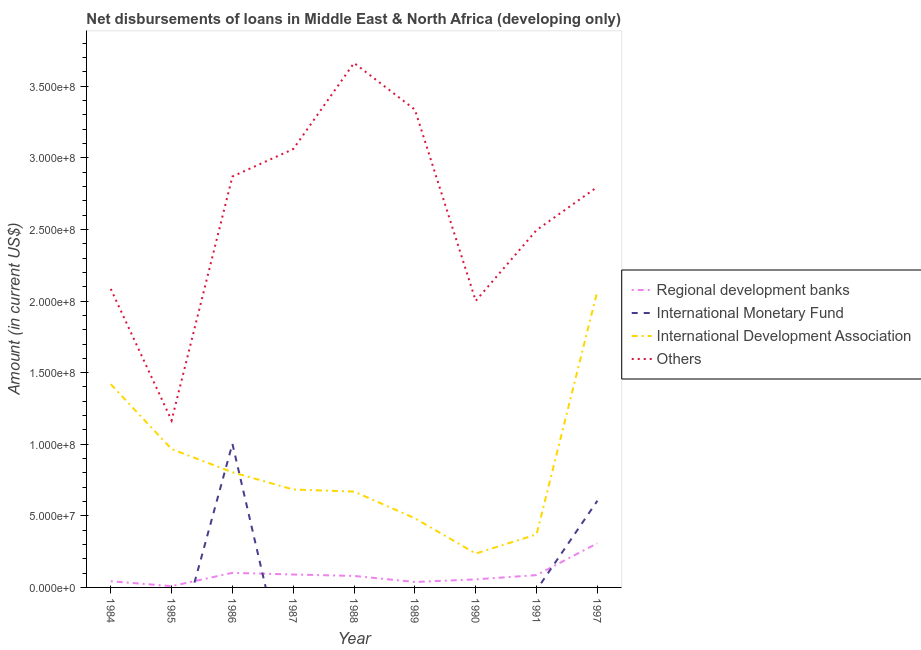Is the number of lines equal to the number of legend labels?
Make the answer very short. No. What is the amount of loan disimbursed by other organisations in 1984?
Ensure brevity in your answer.  2.08e+08. Across all years, what is the maximum amount of loan disimbursed by international monetary fund?
Provide a short and direct response. 1.00e+08. Across all years, what is the minimum amount of loan disimbursed by other organisations?
Keep it short and to the point. 1.17e+08. In which year was the amount of loan disimbursed by regional development banks maximum?
Ensure brevity in your answer.  1997. What is the total amount of loan disimbursed by other organisations in the graph?
Your answer should be very brief. 2.35e+09. What is the difference between the amount of loan disimbursed by other organisations in 1991 and that in 1997?
Ensure brevity in your answer.  -3.02e+07. What is the difference between the amount of loan disimbursed by other organisations in 1997 and the amount of loan disimbursed by international development association in 1988?
Make the answer very short. 2.13e+08. What is the average amount of loan disimbursed by international development association per year?
Provide a short and direct response. 8.56e+07. In the year 1986, what is the difference between the amount of loan disimbursed by other organisations and amount of loan disimbursed by international monetary fund?
Provide a succinct answer. 1.87e+08. What is the ratio of the amount of loan disimbursed by regional development banks in 1986 to that in 1987?
Provide a short and direct response. 1.13. Is the amount of loan disimbursed by regional development banks in 1986 less than that in 1989?
Make the answer very short. No. What is the difference between the highest and the second highest amount of loan disimbursed by other organisations?
Your response must be concise. 3.26e+07. What is the difference between the highest and the lowest amount of loan disimbursed by international monetary fund?
Keep it short and to the point. 1.00e+08. In how many years, is the amount of loan disimbursed by other organisations greater than the average amount of loan disimbursed by other organisations taken over all years?
Give a very brief answer. 5. Is it the case that in every year, the sum of the amount of loan disimbursed by regional development banks and amount of loan disimbursed by international monetary fund is greater than the amount of loan disimbursed by international development association?
Keep it short and to the point. No. Is the amount of loan disimbursed by other organisations strictly less than the amount of loan disimbursed by regional development banks over the years?
Make the answer very short. No. How many lines are there?
Make the answer very short. 4. Are the values on the major ticks of Y-axis written in scientific E-notation?
Ensure brevity in your answer.  Yes. Does the graph contain grids?
Offer a terse response. No. Where does the legend appear in the graph?
Provide a succinct answer. Center right. How many legend labels are there?
Your answer should be very brief. 4. What is the title of the graph?
Provide a succinct answer. Net disbursements of loans in Middle East & North Africa (developing only). What is the label or title of the Y-axis?
Provide a short and direct response. Amount (in current US$). What is the Amount (in current US$) of Regional development banks in 1984?
Make the answer very short. 4.33e+06. What is the Amount (in current US$) in International Development Association in 1984?
Your answer should be very brief. 1.42e+08. What is the Amount (in current US$) in Others in 1984?
Ensure brevity in your answer.  2.08e+08. What is the Amount (in current US$) in Regional development banks in 1985?
Your answer should be compact. 8.91e+05. What is the Amount (in current US$) in International Monetary Fund in 1985?
Your answer should be very brief. 0. What is the Amount (in current US$) of International Development Association in 1985?
Offer a very short reply. 9.66e+07. What is the Amount (in current US$) of Others in 1985?
Provide a short and direct response. 1.17e+08. What is the Amount (in current US$) of Regional development banks in 1986?
Offer a very short reply. 1.02e+07. What is the Amount (in current US$) in International Monetary Fund in 1986?
Provide a short and direct response. 1.00e+08. What is the Amount (in current US$) of International Development Association in 1986?
Provide a succinct answer. 8.04e+07. What is the Amount (in current US$) of Others in 1986?
Offer a very short reply. 2.87e+08. What is the Amount (in current US$) in Regional development banks in 1987?
Offer a very short reply. 9.02e+06. What is the Amount (in current US$) of International Monetary Fund in 1987?
Offer a very short reply. 0. What is the Amount (in current US$) of International Development Association in 1987?
Your answer should be compact. 6.84e+07. What is the Amount (in current US$) of Others in 1987?
Keep it short and to the point. 3.06e+08. What is the Amount (in current US$) in Regional development banks in 1988?
Give a very brief answer. 8.03e+06. What is the Amount (in current US$) of International Monetary Fund in 1988?
Provide a succinct answer. 0. What is the Amount (in current US$) in International Development Association in 1988?
Your response must be concise. 6.69e+07. What is the Amount (in current US$) of Others in 1988?
Ensure brevity in your answer.  3.66e+08. What is the Amount (in current US$) of Regional development banks in 1989?
Offer a very short reply. 3.80e+06. What is the Amount (in current US$) of International Monetary Fund in 1989?
Offer a terse response. 0. What is the Amount (in current US$) in International Development Association in 1989?
Give a very brief answer. 4.83e+07. What is the Amount (in current US$) of Others in 1989?
Provide a short and direct response. 3.34e+08. What is the Amount (in current US$) in Regional development banks in 1990?
Ensure brevity in your answer.  5.62e+06. What is the Amount (in current US$) of International Development Association in 1990?
Keep it short and to the point. 2.37e+07. What is the Amount (in current US$) of Others in 1990?
Offer a very short reply. 2.00e+08. What is the Amount (in current US$) of Regional development banks in 1991?
Your response must be concise. 8.61e+06. What is the Amount (in current US$) in International Development Association in 1991?
Make the answer very short. 3.70e+07. What is the Amount (in current US$) in Others in 1991?
Provide a succinct answer. 2.50e+08. What is the Amount (in current US$) in Regional development banks in 1997?
Offer a terse response. 3.09e+07. What is the Amount (in current US$) of International Monetary Fund in 1997?
Provide a succinct answer. 6.05e+07. What is the Amount (in current US$) in International Development Association in 1997?
Make the answer very short. 2.07e+08. What is the Amount (in current US$) of Others in 1997?
Provide a succinct answer. 2.80e+08. Across all years, what is the maximum Amount (in current US$) of Regional development banks?
Give a very brief answer. 3.09e+07. Across all years, what is the maximum Amount (in current US$) of International Monetary Fund?
Your answer should be compact. 1.00e+08. Across all years, what is the maximum Amount (in current US$) in International Development Association?
Your answer should be very brief. 2.07e+08. Across all years, what is the maximum Amount (in current US$) of Others?
Offer a terse response. 3.66e+08. Across all years, what is the minimum Amount (in current US$) of Regional development banks?
Your answer should be compact. 8.91e+05. Across all years, what is the minimum Amount (in current US$) in International Monetary Fund?
Your answer should be compact. 0. Across all years, what is the minimum Amount (in current US$) of International Development Association?
Ensure brevity in your answer.  2.37e+07. Across all years, what is the minimum Amount (in current US$) of Others?
Provide a short and direct response. 1.17e+08. What is the total Amount (in current US$) of Regional development banks in the graph?
Offer a very short reply. 8.13e+07. What is the total Amount (in current US$) in International Monetary Fund in the graph?
Offer a terse response. 1.61e+08. What is the total Amount (in current US$) in International Development Association in the graph?
Make the answer very short. 7.70e+08. What is the total Amount (in current US$) in Others in the graph?
Provide a succinct answer. 2.35e+09. What is the difference between the Amount (in current US$) of Regional development banks in 1984 and that in 1985?
Your answer should be very brief. 3.44e+06. What is the difference between the Amount (in current US$) of International Development Association in 1984 and that in 1985?
Your answer should be compact. 4.53e+07. What is the difference between the Amount (in current US$) of Others in 1984 and that in 1985?
Offer a very short reply. 9.19e+07. What is the difference between the Amount (in current US$) of Regional development banks in 1984 and that in 1986?
Offer a terse response. -5.86e+06. What is the difference between the Amount (in current US$) in International Development Association in 1984 and that in 1986?
Offer a terse response. 6.15e+07. What is the difference between the Amount (in current US$) of Others in 1984 and that in 1986?
Give a very brief answer. -7.85e+07. What is the difference between the Amount (in current US$) in Regional development banks in 1984 and that in 1987?
Offer a very short reply. -4.69e+06. What is the difference between the Amount (in current US$) of International Development Association in 1984 and that in 1987?
Your answer should be very brief. 7.36e+07. What is the difference between the Amount (in current US$) of Others in 1984 and that in 1987?
Ensure brevity in your answer.  -9.77e+07. What is the difference between the Amount (in current US$) in Regional development banks in 1984 and that in 1988?
Offer a very short reply. -3.70e+06. What is the difference between the Amount (in current US$) of International Development Association in 1984 and that in 1988?
Ensure brevity in your answer.  7.50e+07. What is the difference between the Amount (in current US$) of Others in 1984 and that in 1988?
Provide a succinct answer. -1.58e+08. What is the difference between the Amount (in current US$) in Regional development banks in 1984 and that in 1989?
Keep it short and to the point. 5.32e+05. What is the difference between the Amount (in current US$) in International Development Association in 1984 and that in 1989?
Your answer should be very brief. 9.37e+07. What is the difference between the Amount (in current US$) in Others in 1984 and that in 1989?
Give a very brief answer. -1.25e+08. What is the difference between the Amount (in current US$) of Regional development banks in 1984 and that in 1990?
Make the answer very short. -1.29e+06. What is the difference between the Amount (in current US$) of International Development Association in 1984 and that in 1990?
Your response must be concise. 1.18e+08. What is the difference between the Amount (in current US$) in Others in 1984 and that in 1990?
Provide a short and direct response. 8.32e+06. What is the difference between the Amount (in current US$) of Regional development banks in 1984 and that in 1991?
Keep it short and to the point. -4.28e+06. What is the difference between the Amount (in current US$) in International Development Association in 1984 and that in 1991?
Keep it short and to the point. 1.05e+08. What is the difference between the Amount (in current US$) of Others in 1984 and that in 1991?
Provide a short and direct response. -4.11e+07. What is the difference between the Amount (in current US$) of Regional development banks in 1984 and that in 1997?
Make the answer very short. -2.65e+07. What is the difference between the Amount (in current US$) of International Development Association in 1984 and that in 1997?
Your answer should be very brief. -6.51e+07. What is the difference between the Amount (in current US$) in Others in 1984 and that in 1997?
Offer a very short reply. -7.13e+07. What is the difference between the Amount (in current US$) of Regional development banks in 1985 and that in 1986?
Offer a very short reply. -9.30e+06. What is the difference between the Amount (in current US$) of International Development Association in 1985 and that in 1986?
Offer a very short reply. 1.62e+07. What is the difference between the Amount (in current US$) of Others in 1985 and that in 1986?
Offer a very short reply. -1.70e+08. What is the difference between the Amount (in current US$) in Regional development banks in 1985 and that in 1987?
Your response must be concise. -8.13e+06. What is the difference between the Amount (in current US$) of International Development Association in 1985 and that in 1987?
Provide a short and direct response. 2.83e+07. What is the difference between the Amount (in current US$) in Others in 1985 and that in 1987?
Keep it short and to the point. -1.90e+08. What is the difference between the Amount (in current US$) in Regional development banks in 1985 and that in 1988?
Provide a short and direct response. -7.14e+06. What is the difference between the Amount (in current US$) in International Development Association in 1985 and that in 1988?
Offer a very short reply. 2.97e+07. What is the difference between the Amount (in current US$) of Others in 1985 and that in 1988?
Offer a very short reply. -2.50e+08. What is the difference between the Amount (in current US$) in Regional development banks in 1985 and that in 1989?
Keep it short and to the point. -2.91e+06. What is the difference between the Amount (in current US$) of International Development Association in 1985 and that in 1989?
Offer a very short reply. 4.84e+07. What is the difference between the Amount (in current US$) of Others in 1985 and that in 1989?
Offer a very short reply. -2.17e+08. What is the difference between the Amount (in current US$) of Regional development banks in 1985 and that in 1990?
Your response must be concise. -4.73e+06. What is the difference between the Amount (in current US$) in International Development Association in 1985 and that in 1990?
Provide a short and direct response. 7.30e+07. What is the difference between the Amount (in current US$) of Others in 1985 and that in 1990?
Offer a very short reply. -8.35e+07. What is the difference between the Amount (in current US$) of Regional development banks in 1985 and that in 1991?
Ensure brevity in your answer.  -7.72e+06. What is the difference between the Amount (in current US$) of International Development Association in 1985 and that in 1991?
Make the answer very short. 5.96e+07. What is the difference between the Amount (in current US$) in Others in 1985 and that in 1991?
Your answer should be compact. -1.33e+08. What is the difference between the Amount (in current US$) of Regional development banks in 1985 and that in 1997?
Offer a very short reply. -3.00e+07. What is the difference between the Amount (in current US$) in International Development Association in 1985 and that in 1997?
Offer a very short reply. -1.10e+08. What is the difference between the Amount (in current US$) in Others in 1985 and that in 1997?
Offer a very short reply. -1.63e+08. What is the difference between the Amount (in current US$) of Regional development banks in 1986 and that in 1987?
Keep it short and to the point. 1.17e+06. What is the difference between the Amount (in current US$) of International Development Association in 1986 and that in 1987?
Your answer should be compact. 1.21e+07. What is the difference between the Amount (in current US$) in Others in 1986 and that in 1987?
Give a very brief answer. -1.92e+07. What is the difference between the Amount (in current US$) in Regional development banks in 1986 and that in 1988?
Your response must be concise. 2.16e+06. What is the difference between the Amount (in current US$) of International Development Association in 1986 and that in 1988?
Offer a very short reply. 1.35e+07. What is the difference between the Amount (in current US$) of Others in 1986 and that in 1988?
Ensure brevity in your answer.  -7.93e+07. What is the difference between the Amount (in current US$) in Regional development banks in 1986 and that in 1989?
Offer a terse response. 6.40e+06. What is the difference between the Amount (in current US$) in International Development Association in 1986 and that in 1989?
Offer a terse response. 3.22e+07. What is the difference between the Amount (in current US$) in Others in 1986 and that in 1989?
Your response must be concise. -4.67e+07. What is the difference between the Amount (in current US$) in Regional development banks in 1986 and that in 1990?
Provide a succinct answer. 4.58e+06. What is the difference between the Amount (in current US$) of International Development Association in 1986 and that in 1990?
Give a very brief answer. 5.68e+07. What is the difference between the Amount (in current US$) of Others in 1986 and that in 1990?
Your answer should be very brief. 8.68e+07. What is the difference between the Amount (in current US$) in Regional development banks in 1986 and that in 1991?
Your answer should be very brief. 1.59e+06. What is the difference between the Amount (in current US$) in International Development Association in 1986 and that in 1991?
Offer a terse response. 4.34e+07. What is the difference between the Amount (in current US$) in Others in 1986 and that in 1991?
Provide a succinct answer. 3.74e+07. What is the difference between the Amount (in current US$) in Regional development banks in 1986 and that in 1997?
Your answer should be very brief. -2.07e+07. What is the difference between the Amount (in current US$) of International Monetary Fund in 1986 and that in 1997?
Provide a short and direct response. 3.98e+07. What is the difference between the Amount (in current US$) of International Development Association in 1986 and that in 1997?
Provide a short and direct response. -1.27e+08. What is the difference between the Amount (in current US$) of Others in 1986 and that in 1997?
Offer a very short reply. 7.25e+06. What is the difference between the Amount (in current US$) of Regional development banks in 1987 and that in 1988?
Ensure brevity in your answer.  9.90e+05. What is the difference between the Amount (in current US$) in International Development Association in 1987 and that in 1988?
Your response must be concise. 1.45e+06. What is the difference between the Amount (in current US$) of Others in 1987 and that in 1988?
Ensure brevity in your answer.  -6.01e+07. What is the difference between the Amount (in current US$) in Regional development banks in 1987 and that in 1989?
Your answer should be compact. 5.22e+06. What is the difference between the Amount (in current US$) in International Development Association in 1987 and that in 1989?
Provide a succinct answer. 2.01e+07. What is the difference between the Amount (in current US$) of Others in 1987 and that in 1989?
Keep it short and to the point. -2.76e+07. What is the difference between the Amount (in current US$) in Regional development banks in 1987 and that in 1990?
Keep it short and to the point. 3.40e+06. What is the difference between the Amount (in current US$) in International Development Association in 1987 and that in 1990?
Ensure brevity in your answer.  4.47e+07. What is the difference between the Amount (in current US$) of Others in 1987 and that in 1990?
Give a very brief answer. 1.06e+08. What is the difference between the Amount (in current US$) in Regional development banks in 1987 and that in 1991?
Offer a very short reply. 4.12e+05. What is the difference between the Amount (in current US$) of International Development Association in 1987 and that in 1991?
Offer a very short reply. 3.14e+07. What is the difference between the Amount (in current US$) in Others in 1987 and that in 1991?
Your response must be concise. 5.66e+07. What is the difference between the Amount (in current US$) of Regional development banks in 1987 and that in 1997?
Offer a very short reply. -2.18e+07. What is the difference between the Amount (in current US$) in International Development Association in 1987 and that in 1997?
Your answer should be compact. -1.39e+08. What is the difference between the Amount (in current US$) in Others in 1987 and that in 1997?
Offer a terse response. 2.64e+07. What is the difference between the Amount (in current US$) in Regional development banks in 1988 and that in 1989?
Ensure brevity in your answer.  4.23e+06. What is the difference between the Amount (in current US$) in International Development Association in 1988 and that in 1989?
Provide a succinct answer. 1.87e+07. What is the difference between the Amount (in current US$) in Others in 1988 and that in 1989?
Your answer should be very brief. 3.26e+07. What is the difference between the Amount (in current US$) in Regional development banks in 1988 and that in 1990?
Keep it short and to the point. 2.41e+06. What is the difference between the Amount (in current US$) of International Development Association in 1988 and that in 1990?
Provide a succinct answer. 4.32e+07. What is the difference between the Amount (in current US$) of Others in 1988 and that in 1990?
Your answer should be very brief. 1.66e+08. What is the difference between the Amount (in current US$) in Regional development banks in 1988 and that in 1991?
Your answer should be compact. -5.78e+05. What is the difference between the Amount (in current US$) in International Development Association in 1988 and that in 1991?
Keep it short and to the point. 2.99e+07. What is the difference between the Amount (in current US$) in Others in 1988 and that in 1991?
Make the answer very short. 1.17e+08. What is the difference between the Amount (in current US$) in Regional development banks in 1988 and that in 1997?
Provide a short and direct response. -2.28e+07. What is the difference between the Amount (in current US$) of International Development Association in 1988 and that in 1997?
Provide a succinct answer. -1.40e+08. What is the difference between the Amount (in current US$) of Others in 1988 and that in 1997?
Your response must be concise. 8.65e+07. What is the difference between the Amount (in current US$) of Regional development banks in 1989 and that in 1990?
Provide a succinct answer. -1.82e+06. What is the difference between the Amount (in current US$) in International Development Association in 1989 and that in 1990?
Your response must be concise. 2.46e+07. What is the difference between the Amount (in current US$) of Others in 1989 and that in 1990?
Your answer should be compact. 1.34e+08. What is the difference between the Amount (in current US$) in Regional development banks in 1989 and that in 1991?
Offer a terse response. -4.81e+06. What is the difference between the Amount (in current US$) of International Development Association in 1989 and that in 1991?
Offer a terse response. 1.13e+07. What is the difference between the Amount (in current US$) of Others in 1989 and that in 1991?
Your response must be concise. 8.41e+07. What is the difference between the Amount (in current US$) in Regional development banks in 1989 and that in 1997?
Ensure brevity in your answer.  -2.71e+07. What is the difference between the Amount (in current US$) of International Development Association in 1989 and that in 1997?
Give a very brief answer. -1.59e+08. What is the difference between the Amount (in current US$) of Others in 1989 and that in 1997?
Provide a short and direct response. 5.40e+07. What is the difference between the Amount (in current US$) of Regional development banks in 1990 and that in 1991?
Make the answer very short. -2.99e+06. What is the difference between the Amount (in current US$) in International Development Association in 1990 and that in 1991?
Offer a very short reply. -1.33e+07. What is the difference between the Amount (in current US$) in Others in 1990 and that in 1991?
Give a very brief answer. -4.94e+07. What is the difference between the Amount (in current US$) of Regional development banks in 1990 and that in 1997?
Keep it short and to the point. -2.52e+07. What is the difference between the Amount (in current US$) in International Development Association in 1990 and that in 1997?
Offer a terse response. -1.83e+08. What is the difference between the Amount (in current US$) of Others in 1990 and that in 1997?
Offer a terse response. -7.96e+07. What is the difference between the Amount (in current US$) in Regional development banks in 1991 and that in 1997?
Your response must be concise. -2.22e+07. What is the difference between the Amount (in current US$) in International Development Association in 1991 and that in 1997?
Your response must be concise. -1.70e+08. What is the difference between the Amount (in current US$) in Others in 1991 and that in 1997?
Your response must be concise. -3.02e+07. What is the difference between the Amount (in current US$) of Regional development banks in 1984 and the Amount (in current US$) of International Development Association in 1985?
Your response must be concise. -9.23e+07. What is the difference between the Amount (in current US$) of Regional development banks in 1984 and the Amount (in current US$) of Others in 1985?
Offer a terse response. -1.12e+08. What is the difference between the Amount (in current US$) in International Development Association in 1984 and the Amount (in current US$) in Others in 1985?
Offer a terse response. 2.53e+07. What is the difference between the Amount (in current US$) of Regional development banks in 1984 and the Amount (in current US$) of International Monetary Fund in 1986?
Make the answer very short. -9.60e+07. What is the difference between the Amount (in current US$) of Regional development banks in 1984 and the Amount (in current US$) of International Development Association in 1986?
Make the answer very short. -7.61e+07. What is the difference between the Amount (in current US$) of Regional development banks in 1984 and the Amount (in current US$) of Others in 1986?
Make the answer very short. -2.83e+08. What is the difference between the Amount (in current US$) in International Development Association in 1984 and the Amount (in current US$) in Others in 1986?
Offer a terse response. -1.45e+08. What is the difference between the Amount (in current US$) of Regional development banks in 1984 and the Amount (in current US$) of International Development Association in 1987?
Offer a very short reply. -6.40e+07. What is the difference between the Amount (in current US$) of Regional development banks in 1984 and the Amount (in current US$) of Others in 1987?
Your answer should be compact. -3.02e+08. What is the difference between the Amount (in current US$) of International Development Association in 1984 and the Amount (in current US$) of Others in 1987?
Provide a succinct answer. -1.64e+08. What is the difference between the Amount (in current US$) of Regional development banks in 1984 and the Amount (in current US$) of International Development Association in 1988?
Your answer should be very brief. -6.26e+07. What is the difference between the Amount (in current US$) of Regional development banks in 1984 and the Amount (in current US$) of Others in 1988?
Offer a terse response. -3.62e+08. What is the difference between the Amount (in current US$) of International Development Association in 1984 and the Amount (in current US$) of Others in 1988?
Provide a succinct answer. -2.24e+08. What is the difference between the Amount (in current US$) of Regional development banks in 1984 and the Amount (in current US$) of International Development Association in 1989?
Provide a succinct answer. -4.39e+07. What is the difference between the Amount (in current US$) of Regional development banks in 1984 and the Amount (in current US$) of Others in 1989?
Your answer should be compact. -3.29e+08. What is the difference between the Amount (in current US$) of International Development Association in 1984 and the Amount (in current US$) of Others in 1989?
Your answer should be compact. -1.92e+08. What is the difference between the Amount (in current US$) of Regional development banks in 1984 and the Amount (in current US$) of International Development Association in 1990?
Offer a very short reply. -1.93e+07. What is the difference between the Amount (in current US$) of Regional development banks in 1984 and the Amount (in current US$) of Others in 1990?
Offer a very short reply. -1.96e+08. What is the difference between the Amount (in current US$) in International Development Association in 1984 and the Amount (in current US$) in Others in 1990?
Offer a very short reply. -5.82e+07. What is the difference between the Amount (in current US$) in Regional development banks in 1984 and the Amount (in current US$) in International Development Association in 1991?
Keep it short and to the point. -3.27e+07. What is the difference between the Amount (in current US$) of Regional development banks in 1984 and the Amount (in current US$) of Others in 1991?
Provide a short and direct response. -2.45e+08. What is the difference between the Amount (in current US$) in International Development Association in 1984 and the Amount (in current US$) in Others in 1991?
Ensure brevity in your answer.  -1.08e+08. What is the difference between the Amount (in current US$) in Regional development banks in 1984 and the Amount (in current US$) in International Monetary Fund in 1997?
Your answer should be compact. -5.62e+07. What is the difference between the Amount (in current US$) in Regional development banks in 1984 and the Amount (in current US$) in International Development Association in 1997?
Make the answer very short. -2.03e+08. What is the difference between the Amount (in current US$) of Regional development banks in 1984 and the Amount (in current US$) of Others in 1997?
Offer a very short reply. -2.75e+08. What is the difference between the Amount (in current US$) in International Development Association in 1984 and the Amount (in current US$) in Others in 1997?
Offer a very short reply. -1.38e+08. What is the difference between the Amount (in current US$) in Regional development banks in 1985 and the Amount (in current US$) in International Monetary Fund in 1986?
Make the answer very short. -9.94e+07. What is the difference between the Amount (in current US$) in Regional development banks in 1985 and the Amount (in current US$) in International Development Association in 1986?
Make the answer very short. -7.95e+07. What is the difference between the Amount (in current US$) in Regional development banks in 1985 and the Amount (in current US$) in Others in 1986?
Ensure brevity in your answer.  -2.86e+08. What is the difference between the Amount (in current US$) of International Development Association in 1985 and the Amount (in current US$) of Others in 1986?
Your answer should be compact. -1.90e+08. What is the difference between the Amount (in current US$) of Regional development banks in 1985 and the Amount (in current US$) of International Development Association in 1987?
Ensure brevity in your answer.  -6.75e+07. What is the difference between the Amount (in current US$) in Regional development banks in 1985 and the Amount (in current US$) in Others in 1987?
Ensure brevity in your answer.  -3.05e+08. What is the difference between the Amount (in current US$) of International Development Association in 1985 and the Amount (in current US$) of Others in 1987?
Your answer should be very brief. -2.10e+08. What is the difference between the Amount (in current US$) in Regional development banks in 1985 and the Amount (in current US$) in International Development Association in 1988?
Keep it short and to the point. -6.60e+07. What is the difference between the Amount (in current US$) of Regional development banks in 1985 and the Amount (in current US$) of Others in 1988?
Your response must be concise. -3.65e+08. What is the difference between the Amount (in current US$) of International Development Association in 1985 and the Amount (in current US$) of Others in 1988?
Offer a terse response. -2.70e+08. What is the difference between the Amount (in current US$) of Regional development banks in 1985 and the Amount (in current US$) of International Development Association in 1989?
Offer a very short reply. -4.74e+07. What is the difference between the Amount (in current US$) of Regional development banks in 1985 and the Amount (in current US$) of Others in 1989?
Provide a short and direct response. -3.33e+08. What is the difference between the Amount (in current US$) of International Development Association in 1985 and the Amount (in current US$) of Others in 1989?
Your answer should be very brief. -2.37e+08. What is the difference between the Amount (in current US$) of Regional development banks in 1985 and the Amount (in current US$) of International Development Association in 1990?
Make the answer very short. -2.28e+07. What is the difference between the Amount (in current US$) of Regional development banks in 1985 and the Amount (in current US$) of Others in 1990?
Offer a terse response. -1.99e+08. What is the difference between the Amount (in current US$) of International Development Association in 1985 and the Amount (in current US$) of Others in 1990?
Ensure brevity in your answer.  -1.04e+08. What is the difference between the Amount (in current US$) of Regional development banks in 1985 and the Amount (in current US$) of International Development Association in 1991?
Provide a succinct answer. -3.61e+07. What is the difference between the Amount (in current US$) of Regional development banks in 1985 and the Amount (in current US$) of Others in 1991?
Your response must be concise. -2.49e+08. What is the difference between the Amount (in current US$) in International Development Association in 1985 and the Amount (in current US$) in Others in 1991?
Your answer should be compact. -1.53e+08. What is the difference between the Amount (in current US$) in Regional development banks in 1985 and the Amount (in current US$) in International Monetary Fund in 1997?
Provide a succinct answer. -5.97e+07. What is the difference between the Amount (in current US$) in Regional development banks in 1985 and the Amount (in current US$) in International Development Association in 1997?
Keep it short and to the point. -2.06e+08. What is the difference between the Amount (in current US$) in Regional development banks in 1985 and the Amount (in current US$) in Others in 1997?
Offer a very short reply. -2.79e+08. What is the difference between the Amount (in current US$) of International Development Association in 1985 and the Amount (in current US$) of Others in 1997?
Your response must be concise. -1.83e+08. What is the difference between the Amount (in current US$) of Regional development banks in 1986 and the Amount (in current US$) of International Development Association in 1987?
Your answer should be compact. -5.82e+07. What is the difference between the Amount (in current US$) in Regional development banks in 1986 and the Amount (in current US$) in Others in 1987?
Ensure brevity in your answer.  -2.96e+08. What is the difference between the Amount (in current US$) of International Monetary Fund in 1986 and the Amount (in current US$) of International Development Association in 1987?
Give a very brief answer. 3.19e+07. What is the difference between the Amount (in current US$) of International Monetary Fund in 1986 and the Amount (in current US$) of Others in 1987?
Ensure brevity in your answer.  -2.06e+08. What is the difference between the Amount (in current US$) in International Development Association in 1986 and the Amount (in current US$) in Others in 1987?
Offer a very short reply. -2.26e+08. What is the difference between the Amount (in current US$) of Regional development banks in 1986 and the Amount (in current US$) of International Development Association in 1988?
Offer a terse response. -5.67e+07. What is the difference between the Amount (in current US$) in Regional development banks in 1986 and the Amount (in current US$) in Others in 1988?
Provide a short and direct response. -3.56e+08. What is the difference between the Amount (in current US$) of International Monetary Fund in 1986 and the Amount (in current US$) of International Development Association in 1988?
Give a very brief answer. 3.34e+07. What is the difference between the Amount (in current US$) of International Monetary Fund in 1986 and the Amount (in current US$) of Others in 1988?
Your answer should be very brief. -2.66e+08. What is the difference between the Amount (in current US$) of International Development Association in 1986 and the Amount (in current US$) of Others in 1988?
Provide a short and direct response. -2.86e+08. What is the difference between the Amount (in current US$) of Regional development banks in 1986 and the Amount (in current US$) of International Development Association in 1989?
Your response must be concise. -3.81e+07. What is the difference between the Amount (in current US$) in Regional development banks in 1986 and the Amount (in current US$) in Others in 1989?
Provide a succinct answer. -3.24e+08. What is the difference between the Amount (in current US$) in International Monetary Fund in 1986 and the Amount (in current US$) in International Development Association in 1989?
Your answer should be very brief. 5.20e+07. What is the difference between the Amount (in current US$) of International Monetary Fund in 1986 and the Amount (in current US$) of Others in 1989?
Offer a very short reply. -2.33e+08. What is the difference between the Amount (in current US$) in International Development Association in 1986 and the Amount (in current US$) in Others in 1989?
Offer a very short reply. -2.53e+08. What is the difference between the Amount (in current US$) in Regional development banks in 1986 and the Amount (in current US$) in International Development Association in 1990?
Your answer should be very brief. -1.35e+07. What is the difference between the Amount (in current US$) of Regional development banks in 1986 and the Amount (in current US$) of Others in 1990?
Offer a terse response. -1.90e+08. What is the difference between the Amount (in current US$) in International Monetary Fund in 1986 and the Amount (in current US$) in International Development Association in 1990?
Ensure brevity in your answer.  7.66e+07. What is the difference between the Amount (in current US$) in International Monetary Fund in 1986 and the Amount (in current US$) in Others in 1990?
Make the answer very short. -9.98e+07. What is the difference between the Amount (in current US$) of International Development Association in 1986 and the Amount (in current US$) of Others in 1990?
Keep it short and to the point. -1.20e+08. What is the difference between the Amount (in current US$) in Regional development banks in 1986 and the Amount (in current US$) in International Development Association in 1991?
Provide a short and direct response. -2.68e+07. What is the difference between the Amount (in current US$) of Regional development banks in 1986 and the Amount (in current US$) of Others in 1991?
Offer a terse response. -2.39e+08. What is the difference between the Amount (in current US$) in International Monetary Fund in 1986 and the Amount (in current US$) in International Development Association in 1991?
Give a very brief answer. 6.33e+07. What is the difference between the Amount (in current US$) in International Monetary Fund in 1986 and the Amount (in current US$) in Others in 1991?
Offer a terse response. -1.49e+08. What is the difference between the Amount (in current US$) in International Development Association in 1986 and the Amount (in current US$) in Others in 1991?
Give a very brief answer. -1.69e+08. What is the difference between the Amount (in current US$) of Regional development banks in 1986 and the Amount (in current US$) of International Monetary Fund in 1997?
Your answer should be compact. -5.04e+07. What is the difference between the Amount (in current US$) of Regional development banks in 1986 and the Amount (in current US$) of International Development Association in 1997?
Provide a short and direct response. -1.97e+08. What is the difference between the Amount (in current US$) of Regional development banks in 1986 and the Amount (in current US$) of Others in 1997?
Provide a succinct answer. -2.70e+08. What is the difference between the Amount (in current US$) of International Monetary Fund in 1986 and the Amount (in current US$) of International Development Association in 1997?
Keep it short and to the point. -1.07e+08. What is the difference between the Amount (in current US$) of International Monetary Fund in 1986 and the Amount (in current US$) of Others in 1997?
Make the answer very short. -1.79e+08. What is the difference between the Amount (in current US$) of International Development Association in 1986 and the Amount (in current US$) of Others in 1997?
Your answer should be very brief. -1.99e+08. What is the difference between the Amount (in current US$) in Regional development banks in 1987 and the Amount (in current US$) in International Development Association in 1988?
Give a very brief answer. -5.79e+07. What is the difference between the Amount (in current US$) of Regional development banks in 1987 and the Amount (in current US$) of Others in 1988?
Ensure brevity in your answer.  -3.57e+08. What is the difference between the Amount (in current US$) of International Development Association in 1987 and the Amount (in current US$) of Others in 1988?
Keep it short and to the point. -2.98e+08. What is the difference between the Amount (in current US$) in Regional development banks in 1987 and the Amount (in current US$) in International Development Association in 1989?
Your response must be concise. -3.92e+07. What is the difference between the Amount (in current US$) of Regional development banks in 1987 and the Amount (in current US$) of Others in 1989?
Make the answer very short. -3.25e+08. What is the difference between the Amount (in current US$) in International Development Association in 1987 and the Amount (in current US$) in Others in 1989?
Make the answer very short. -2.65e+08. What is the difference between the Amount (in current US$) of Regional development banks in 1987 and the Amount (in current US$) of International Development Association in 1990?
Your answer should be very brief. -1.47e+07. What is the difference between the Amount (in current US$) of Regional development banks in 1987 and the Amount (in current US$) of Others in 1990?
Your answer should be very brief. -1.91e+08. What is the difference between the Amount (in current US$) in International Development Association in 1987 and the Amount (in current US$) in Others in 1990?
Offer a very short reply. -1.32e+08. What is the difference between the Amount (in current US$) in Regional development banks in 1987 and the Amount (in current US$) in International Development Association in 1991?
Ensure brevity in your answer.  -2.80e+07. What is the difference between the Amount (in current US$) in Regional development banks in 1987 and the Amount (in current US$) in Others in 1991?
Give a very brief answer. -2.41e+08. What is the difference between the Amount (in current US$) of International Development Association in 1987 and the Amount (in current US$) of Others in 1991?
Your answer should be compact. -1.81e+08. What is the difference between the Amount (in current US$) in Regional development banks in 1987 and the Amount (in current US$) in International Monetary Fund in 1997?
Offer a very short reply. -5.15e+07. What is the difference between the Amount (in current US$) of Regional development banks in 1987 and the Amount (in current US$) of International Development Association in 1997?
Provide a short and direct response. -1.98e+08. What is the difference between the Amount (in current US$) in Regional development banks in 1987 and the Amount (in current US$) in Others in 1997?
Give a very brief answer. -2.71e+08. What is the difference between the Amount (in current US$) in International Development Association in 1987 and the Amount (in current US$) in Others in 1997?
Give a very brief answer. -2.11e+08. What is the difference between the Amount (in current US$) in Regional development banks in 1988 and the Amount (in current US$) in International Development Association in 1989?
Give a very brief answer. -4.02e+07. What is the difference between the Amount (in current US$) of Regional development banks in 1988 and the Amount (in current US$) of Others in 1989?
Your response must be concise. -3.26e+08. What is the difference between the Amount (in current US$) of International Development Association in 1988 and the Amount (in current US$) of Others in 1989?
Your answer should be compact. -2.67e+08. What is the difference between the Amount (in current US$) of Regional development banks in 1988 and the Amount (in current US$) of International Development Association in 1990?
Give a very brief answer. -1.56e+07. What is the difference between the Amount (in current US$) of Regional development banks in 1988 and the Amount (in current US$) of Others in 1990?
Make the answer very short. -1.92e+08. What is the difference between the Amount (in current US$) in International Development Association in 1988 and the Amount (in current US$) in Others in 1990?
Ensure brevity in your answer.  -1.33e+08. What is the difference between the Amount (in current US$) of Regional development banks in 1988 and the Amount (in current US$) of International Development Association in 1991?
Give a very brief answer. -2.90e+07. What is the difference between the Amount (in current US$) of Regional development banks in 1988 and the Amount (in current US$) of Others in 1991?
Offer a terse response. -2.42e+08. What is the difference between the Amount (in current US$) in International Development Association in 1988 and the Amount (in current US$) in Others in 1991?
Your answer should be very brief. -1.83e+08. What is the difference between the Amount (in current US$) of Regional development banks in 1988 and the Amount (in current US$) of International Monetary Fund in 1997?
Give a very brief answer. -5.25e+07. What is the difference between the Amount (in current US$) of Regional development banks in 1988 and the Amount (in current US$) of International Development Association in 1997?
Ensure brevity in your answer.  -1.99e+08. What is the difference between the Amount (in current US$) in Regional development banks in 1988 and the Amount (in current US$) in Others in 1997?
Give a very brief answer. -2.72e+08. What is the difference between the Amount (in current US$) of International Development Association in 1988 and the Amount (in current US$) of Others in 1997?
Make the answer very short. -2.13e+08. What is the difference between the Amount (in current US$) in Regional development banks in 1989 and the Amount (in current US$) in International Development Association in 1990?
Give a very brief answer. -1.99e+07. What is the difference between the Amount (in current US$) in Regional development banks in 1989 and the Amount (in current US$) in Others in 1990?
Make the answer very short. -1.96e+08. What is the difference between the Amount (in current US$) of International Development Association in 1989 and the Amount (in current US$) of Others in 1990?
Keep it short and to the point. -1.52e+08. What is the difference between the Amount (in current US$) in Regional development banks in 1989 and the Amount (in current US$) in International Development Association in 1991?
Offer a very short reply. -3.32e+07. What is the difference between the Amount (in current US$) of Regional development banks in 1989 and the Amount (in current US$) of Others in 1991?
Your answer should be very brief. -2.46e+08. What is the difference between the Amount (in current US$) in International Development Association in 1989 and the Amount (in current US$) in Others in 1991?
Ensure brevity in your answer.  -2.01e+08. What is the difference between the Amount (in current US$) of Regional development banks in 1989 and the Amount (in current US$) of International Monetary Fund in 1997?
Your response must be concise. -5.68e+07. What is the difference between the Amount (in current US$) in Regional development banks in 1989 and the Amount (in current US$) in International Development Association in 1997?
Your answer should be very brief. -2.03e+08. What is the difference between the Amount (in current US$) of Regional development banks in 1989 and the Amount (in current US$) of Others in 1997?
Your response must be concise. -2.76e+08. What is the difference between the Amount (in current US$) in International Development Association in 1989 and the Amount (in current US$) in Others in 1997?
Your answer should be compact. -2.31e+08. What is the difference between the Amount (in current US$) in Regional development banks in 1990 and the Amount (in current US$) in International Development Association in 1991?
Ensure brevity in your answer.  -3.14e+07. What is the difference between the Amount (in current US$) of Regional development banks in 1990 and the Amount (in current US$) of Others in 1991?
Your answer should be compact. -2.44e+08. What is the difference between the Amount (in current US$) in International Development Association in 1990 and the Amount (in current US$) in Others in 1991?
Your answer should be very brief. -2.26e+08. What is the difference between the Amount (in current US$) in Regional development banks in 1990 and the Amount (in current US$) in International Monetary Fund in 1997?
Your answer should be compact. -5.49e+07. What is the difference between the Amount (in current US$) of Regional development banks in 1990 and the Amount (in current US$) of International Development Association in 1997?
Give a very brief answer. -2.01e+08. What is the difference between the Amount (in current US$) in Regional development banks in 1990 and the Amount (in current US$) in Others in 1997?
Give a very brief answer. -2.74e+08. What is the difference between the Amount (in current US$) in International Development Association in 1990 and the Amount (in current US$) in Others in 1997?
Your answer should be very brief. -2.56e+08. What is the difference between the Amount (in current US$) of Regional development banks in 1991 and the Amount (in current US$) of International Monetary Fund in 1997?
Provide a succinct answer. -5.19e+07. What is the difference between the Amount (in current US$) in Regional development banks in 1991 and the Amount (in current US$) in International Development Association in 1997?
Your answer should be compact. -1.98e+08. What is the difference between the Amount (in current US$) in Regional development banks in 1991 and the Amount (in current US$) in Others in 1997?
Provide a short and direct response. -2.71e+08. What is the difference between the Amount (in current US$) of International Development Association in 1991 and the Amount (in current US$) of Others in 1997?
Keep it short and to the point. -2.43e+08. What is the average Amount (in current US$) of Regional development banks per year?
Your answer should be very brief. 9.04e+06. What is the average Amount (in current US$) in International Monetary Fund per year?
Your response must be concise. 1.79e+07. What is the average Amount (in current US$) in International Development Association per year?
Your response must be concise. 8.56e+07. What is the average Amount (in current US$) in Others per year?
Offer a very short reply. 2.61e+08. In the year 1984, what is the difference between the Amount (in current US$) of Regional development banks and Amount (in current US$) of International Development Association?
Provide a succinct answer. -1.38e+08. In the year 1984, what is the difference between the Amount (in current US$) of Regional development banks and Amount (in current US$) of Others?
Your answer should be compact. -2.04e+08. In the year 1984, what is the difference between the Amount (in current US$) of International Development Association and Amount (in current US$) of Others?
Your response must be concise. -6.65e+07. In the year 1985, what is the difference between the Amount (in current US$) of Regional development banks and Amount (in current US$) of International Development Association?
Provide a short and direct response. -9.57e+07. In the year 1985, what is the difference between the Amount (in current US$) of Regional development banks and Amount (in current US$) of Others?
Provide a succinct answer. -1.16e+08. In the year 1985, what is the difference between the Amount (in current US$) of International Development Association and Amount (in current US$) of Others?
Your response must be concise. -2.00e+07. In the year 1986, what is the difference between the Amount (in current US$) in Regional development banks and Amount (in current US$) in International Monetary Fund?
Provide a succinct answer. -9.01e+07. In the year 1986, what is the difference between the Amount (in current US$) of Regional development banks and Amount (in current US$) of International Development Association?
Your answer should be compact. -7.02e+07. In the year 1986, what is the difference between the Amount (in current US$) of Regional development banks and Amount (in current US$) of Others?
Provide a succinct answer. -2.77e+08. In the year 1986, what is the difference between the Amount (in current US$) of International Monetary Fund and Amount (in current US$) of International Development Association?
Your answer should be very brief. 1.99e+07. In the year 1986, what is the difference between the Amount (in current US$) in International Monetary Fund and Amount (in current US$) in Others?
Your response must be concise. -1.87e+08. In the year 1986, what is the difference between the Amount (in current US$) of International Development Association and Amount (in current US$) of Others?
Your answer should be very brief. -2.07e+08. In the year 1987, what is the difference between the Amount (in current US$) of Regional development banks and Amount (in current US$) of International Development Association?
Make the answer very short. -5.94e+07. In the year 1987, what is the difference between the Amount (in current US$) in Regional development banks and Amount (in current US$) in Others?
Give a very brief answer. -2.97e+08. In the year 1987, what is the difference between the Amount (in current US$) of International Development Association and Amount (in current US$) of Others?
Your answer should be very brief. -2.38e+08. In the year 1988, what is the difference between the Amount (in current US$) in Regional development banks and Amount (in current US$) in International Development Association?
Keep it short and to the point. -5.89e+07. In the year 1988, what is the difference between the Amount (in current US$) in Regional development banks and Amount (in current US$) in Others?
Offer a terse response. -3.58e+08. In the year 1988, what is the difference between the Amount (in current US$) of International Development Association and Amount (in current US$) of Others?
Give a very brief answer. -2.99e+08. In the year 1989, what is the difference between the Amount (in current US$) of Regional development banks and Amount (in current US$) of International Development Association?
Give a very brief answer. -4.45e+07. In the year 1989, what is the difference between the Amount (in current US$) of Regional development banks and Amount (in current US$) of Others?
Offer a terse response. -3.30e+08. In the year 1989, what is the difference between the Amount (in current US$) in International Development Association and Amount (in current US$) in Others?
Make the answer very short. -2.85e+08. In the year 1990, what is the difference between the Amount (in current US$) of Regional development banks and Amount (in current US$) of International Development Association?
Make the answer very short. -1.81e+07. In the year 1990, what is the difference between the Amount (in current US$) in Regional development banks and Amount (in current US$) in Others?
Provide a short and direct response. -1.95e+08. In the year 1990, what is the difference between the Amount (in current US$) of International Development Association and Amount (in current US$) of Others?
Provide a succinct answer. -1.76e+08. In the year 1991, what is the difference between the Amount (in current US$) in Regional development banks and Amount (in current US$) in International Development Association?
Provide a short and direct response. -2.84e+07. In the year 1991, what is the difference between the Amount (in current US$) of Regional development banks and Amount (in current US$) of Others?
Provide a succinct answer. -2.41e+08. In the year 1991, what is the difference between the Amount (in current US$) in International Development Association and Amount (in current US$) in Others?
Your answer should be very brief. -2.13e+08. In the year 1997, what is the difference between the Amount (in current US$) in Regional development banks and Amount (in current US$) in International Monetary Fund?
Offer a very short reply. -2.97e+07. In the year 1997, what is the difference between the Amount (in current US$) of Regional development banks and Amount (in current US$) of International Development Association?
Provide a short and direct response. -1.76e+08. In the year 1997, what is the difference between the Amount (in current US$) in Regional development banks and Amount (in current US$) in Others?
Ensure brevity in your answer.  -2.49e+08. In the year 1997, what is the difference between the Amount (in current US$) of International Monetary Fund and Amount (in current US$) of International Development Association?
Ensure brevity in your answer.  -1.47e+08. In the year 1997, what is the difference between the Amount (in current US$) in International Monetary Fund and Amount (in current US$) in Others?
Offer a terse response. -2.19e+08. In the year 1997, what is the difference between the Amount (in current US$) in International Development Association and Amount (in current US$) in Others?
Your response must be concise. -7.27e+07. What is the ratio of the Amount (in current US$) in Regional development banks in 1984 to that in 1985?
Keep it short and to the point. 4.86. What is the ratio of the Amount (in current US$) in International Development Association in 1984 to that in 1985?
Keep it short and to the point. 1.47. What is the ratio of the Amount (in current US$) of Others in 1984 to that in 1985?
Keep it short and to the point. 1.79. What is the ratio of the Amount (in current US$) in Regional development banks in 1984 to that in 1986?
Your response must be concise. 0.42. What is the ratio of the Amount (in current US$) of International Development Association in 1984 to that in 1986?
Provide a succinct answer. 1.76. What is the ratio of the Amount (in current US$) of Others in 1984 to that in 1986?
Provide a succinct answer. 0.73. What is the ratio of the Amount (in current US$) in Regional development banks in 1984 to that in 1987?
Your answer should be compact. 0.48. What is the ratio of the Amount (in current US$) in International Development Association in 1984 to that in 1987?
Ensure brevity in your answer.  2.08. What is the ratio of the Amount (in current US$) in Others in 1984 to that in 1987?
Provide a short and direct response. 0.68. What is the ratio of the Amount (in current US$) in Regional development banks in 1984 to that in 1988?
Your response must be concise. 0.54. What is the ratio of the Amount (in current US$) in International Development Association in 1984 to that in 1988?
Give a very brief answer. 2.12. What is the ratio of the Amount (in current US$) of Others in 1984 to that in 1988?
Make the answer very short. 0.57. What is the ratio of the Amount (in current US$) in Regional development banks in 1984 to that in 1989?
Your answer should be very brief. 1.14. What is the ratio of the Amount (in current US$) of International Development Association in 1984 to that in 1989?
Provide a short and direct response. 2.94. What is the ratio of the Amount (in current US$) of Others in 1984 to that in 1989?
Your answer should be compact. 0.62. What is the ratio of the Amount (in current US$) in Regional development banks in 1984 to that in 1990?
Keep it short and to the point. 0.77. What is the ratio of the Amount (in current US$) of International Development Association in 1984 to that in 1990?
Provide a short and direct response. 6. What is the ratio of the Amount (in current US$) of Others in 1984 to that in 1990?
Your answer should be compact. 1.04. What is the ratio of the Amount (in current US$) of Regional development banks in 1984 to that in 1991?
Keep it short and to the point. 0.5. What is the ratio of the Amount (in current US$) of International Development Association in 1984 to that in 1991?
Provide a short and direct response. 3.84. What is the ratio of the Amount (in current US$) in Others in 1984 to that in 1991?
Provide a succinct answer. 0.84. What is the ratio of the Amount (in current US$) of Regional development banks in 1984 to that in 1997?
Your response must be concise. 0.14. What is the ratio of the Amount (in current US$) in International Development Association in 1984 to that in 1997?
Make the answer very short. 0.69. What is the ratio of the Amount (in current US$) of Others in 1984 to that in 1997?
Provide a succinct answer. 0.75. What is the ratio of the Amount (in current US$) of Regional development banks in 1985 to that in 1986?
Your answer should be very brief. 0.09. What is the ratio of the Amount (in current US$) of International Development Association in 1985 to that in 1986?
Offer a very short reply. 1.2. What is the ratio of the Amount (in current US$) in Others in 1985 to that in 1986?
Offer a very short reply. 0.41. What is the ratio of the Amount (in current US$) in Regional development banks in 1985 to that in 1987?
Offer a terse response. 0.1. What is the ratio of the Amount (in current US$) in International Development Association in 1985 to that in 1987?
Provide a short and direct response. 1.41. What is the ratio of the Amount (in current US$) in Others in 1985 to that in 1987?
Offer a terse response. 0.38. What is the ratio of the Amount (in current US$) in Regional development banks in 1985 to that in 1988?
Your answer should be very brief. 0.11. What is the ratio of the Amount (in current US$) in International Development Association in 1985 to that in 1988?
Your answer should be compact. 1.44. What is the ratio of the Amount (in current US$) in Others in 1985 to that in 1988?
Your answer should be compact. 0.32. What is the ratio of the Amount (in current US$) of Regional development banks in 1985 to that in 1989?
Give a very brief answer. 0.23. What is the ratio of the Amount (in current US$) of International Development Association in 1985 to that in 1989?
Your answer should be very brief. 2. What is the ratio of the Amount (in current US$) in Others in 1985 to that in 1989?
Ensure brevity in your answer.  0.35. What is the ratio of the Amount (in current US$) in Regional development banks in 1985 to that in 1990?
Your answer should be very brief. 0.16. What is the ratio of the Amount (in current US$) of International Development Association in 1985 to that in 1990?
Offer a very short reply. 4.08. What is the ratio of the Amount (in current US$) of Others in 1985 to that in 1990?
Keep it short and to the point. 0.58. What is the ratio of the Amount (in current US$) in Regional development banks in 1985 to that in 1991?
Offer a terse response. 0.1. What is the ratio of the Amount (in current US$) of International Development Association in 1985 to that in 1991?
Your response must be concise. 2.61. What is the ratio of the Amount (in current US$) in Others in 1985 to that in 1991?
Offer a terse response. 0.47. What is the ratio of the Amount (in current US$) of Regional development banks in 1985 to that in 1997?
Your answer should be very brief. 0.03. What is the ratio of the Amount (in current US$) in International Development Association in 1985 to that in 1997?
Give a very brief answer. 0.47. What is the ratio of the Amount (in current US$) in Others in 1985 to that in 1997?
Offer a terse response. 0.42. What is the ratio of the Amount (in current US$) in Regional development banks in 1986 to that in 1987?
Keep it short and to the point. 1.13. What is the ratio of the Amount (in current US$) in International Development Association in 1986 to that in 1987?
Your answer should be compact. 1.18. What is the ratio of the Amount (in current US$) in Others in 1986 to that in 1987?
Offer a terse response. 0.94. What is the ratio of the Amount (in current US$) in Regional development banks in 1986 to that in 1988?
Make the answer very short. 1.27. What is the ratio of the Amount (in current US$) in International Development Association in 1986 to that in 1988?
Your response must be concise. 1.2. What is the ratio of the Amount (in current US$) in Others in 1986 to that in 1988?
Offer a very short reply. 0.78. What is the ratio of the Amount (in current US$) of Regional development banks in 1986 to that in 1989?
Make the answer very short. 2.68. What is the ratio of the Amount (in current US$) of International Development Association in 1986 to that in 1989?
Your answer should be very brief. 1.67. What is the ratio of the Amount (in current US$) of Others in 1986 to that in 1989?
Your answer should be very brief. 0.86. What is the ratio of the Amount (in current US$) of Regional development banks in 1986 to that in 1990?
Offer a terse response. 1.81. What is the ratio of the Amount (in current US$) in International Development Association in 1986 to that in 1990?
Your response must be concise. 3.4. What is the ratio of the Amount (in current US$) in Others in 1986 to that in 1990?
Keep it short and to the point. 1.43. What is the ratio of the Amount (in current US$) in Regional development banks in 1986 to that in 1991?
Provide a succinct answer. 1.18. What is the ratio of the Amount (in current US$) of International Development Association in 1986 to that in 1991?
Provide a succinct answer. 2.17. What is the ratio of the Amount (in current US$) of Others in 1986 to that in 1991?
Provide a succinct answer. 1.15. What is the ratio of the Amount (in current US$) of Regional development banks in 1986 to that in 1997?
Keep it short and to the point. 0.33. What is the ratio of the Amount (in current US$) of International Monetary Fund in 1986 to that in 1997?
Make the answer very short. 1.66. What is the ratio of the Amount (in current US$) in International Development Association in 1986 to that in 1997?
Offer a terse response. 0.39. What is the ratio of the Amount (in current US$) of Others in 1986 to that in 1997?
Ensure brevity in your answer.  1.03. What is the ratio of the Amount (in current US$) of Regional development banks in 1987 to that in 1988?
Your response must be concise. 1.12. What is the ratio of the Amount (in current US$) in International Development Association in 1987 to that in 1988?
Ensure brevity in your answer.  1.02. What is the ratio of the Amount (in current US$) of Others in 1987 to that in 1988?
Your answer should be compact. 0.84. What is the ratio of the Amount (in current US$) of Regional development banks in 1987 to that in 1989?
Your answer should be very brief. 2.38. What is the ratio of the Amount (in current US$) in International Development Association in 1987 to that in 1989?
Ensure brevity in your answer.  1.42. What is the ratio of the Amount (in current US$) in Others in 1987 to that in 1989?
Keep it short and to the point. 0.92. What is the ratio of the Amount (in current US$) of Regional development banks in 1987 to that in 1990?
Your answer should be very brief. 1.61. What is the ratio of the Amount (in current US$) of International Development Association in 1987 to that in 1990?
Your answer should be compact. 2.89. What is the ratio of the Amount (in current US$) of Others in 1987 to that in 1990?
Offer a terse response. 1.53. What is the ratio of the Amount (in current US$) in Regional development banks in 1987 to that in 1991?
Provide a short and direct response. 1.05. What is the ratio of the Amount (in current US$) of International Development Association in 1987 to that in 1991?
Your answer should be very brief. 1.85. What is the ratio of the Amount (in current US$) of Others in 1987 to that in 1991?
Offer a terse response. 1.23. What is the ratio of the Amount (in current US$) of Regional development banks in 1987 to that in 1997?
Give a very brief answer. 0.29. What is the ratio of the Amount (in current US$) in International Development Association in 1987 to that in 1997?
Keep it short and to the point. 0.33. What is the ratio of the Amount (in current US$) in Others in 1987 to that in 1997?
Keep it short and to the point. 1.09. What is the ratio of the Amount (in current US$) in Regional development banks in 1988 to that in 1989?
Ensure brevity in your answer.  2.11. What is the ratio of the Amount (in current US$) in International Development Association in 1988 to that in 1989?
Offer a terse response. 1.39. What is the ratio of the Amount (in current US$) in Others in 1988 to that in 1989?
Your answer should be very brief. 1.1. What is the ratio of the Amount (in current US$) of Regional development banks in 1988 to that in 1990?
Your answer should be very brief. 1.43. What is the ratio of the Amount (in current US$) of International Development Association in 1988 to that in 1990?
Provide a succinct answer. 2.83. What is the ratio of the Amount (in current US$) in Others in 1988 to that in 1990?
Provide a short and direct response. 1.83. What is the ratio of the Amount (in current US$) in Regional development banks in 1988 to that in 1991?
Give a very brief answer. 0.93. What is the ratio of the Amount (in current US$) in International Development Association in 1988 to that in 1991?
Make the answer very short. 1.81. What is the ratio of the Amount (in current US$) in Others in 1988 to that in 1991?
Provide a succinct answer. 1.47. What is the ratio of the Amount (in current US$) of Regional development banks in 1988 to that in 1997?
Make the answer very short. 0.26. What is the ratio of the Amount (in current US$) in International Development Association in 1988 to that in 1997?
Provide a succinct answer. 0.32. What is the ratio of the Amount (in current US$) of Others in 1988 to that in 1997?
Make the answer very short. 1.31. What is the ratio of the Amount (in current US$) of Regional development banks in 1989 to that in 1990?
Ensure brevity in your answer.  0.68. What is the ratio of the Amount (in current US$) of International Development Association in 1989 to that in 1990?
Provide a short and direct response. 2.04. What is the ratio of the Amount (in current US$) of Others in 1989 to that in 1990?
Your answer should be very brief. 1.67. What is the ratio of the Amount (in current US$) in Regional development banks in 1989 to that in 1991?
Offer a terse response. 0.44. What is the ratio of the Amount (in current US$) of International Development Association in 1989 to that in 1991?
Keep it short and to the point. 1.3. What is the ratio of the Amount (in current US$) in Others in 1989 to that in 1991?
Give a very brief answer. 1.34. What is the ratio of the Amount (in current US$) of Regional development banks in 1989 to that in 1997?
Your response must be concise. 0.12. What is the ratio of the Amount (in current US$) of International Development Association in 1989 to that in 1997?
Provide a short and direct response. 0.23. What is the ratio of the Amount (in current US$) of Others in 1989 to that in 1997?
Offer a terse response. 1.19. What is the ratio of the Amount (in current US$) in Regional development banks in 1990 to that in 1991?
Provide a succinct answer. 0.65. What is the ratio of the Amount (in current US$) of International Development Association in 1990 to that in 1991?
Your answer should be very brief. 0.64. What is the ratio of the Amount (in current US$) of Others in 1990 to that in 1991?
Keep it short and to the point. 0.8. What is the ratio of the Amount (in current US$) of Regional development banks in 1990 to that in 1997?
Offer a terse response. 0.18. What is the ratio of the Amount (in current US$) of International Development Association in 1990 to that in 1997?
Keep it short and to the point. 0.11. What is the ratio of the Amount (in current US$) of Others in 1990 to that in 1997?
Make the answer very short. 0.72. What is the ratio of the Amount (in current US$) in Regional development banks in 1991 to that in 1997?
Your answer should be compact. 0.28. What is the ratio of the Amount (in current US$) in International Development Association in 1991 to that in 1997?
Ensure brevity in your answer.  0.18. What is the ratio of the Amount (in current US$) in Others in 1991 to that in 1997?
Keep it short and to the point. 0.89. What is the difference between the highest and the second highest Amount (in current US$) in Regional development banks?
Provide a short and direct response. 2.07e+07. What is the difference between the highest and the second highest Amount (in current US$) in International Development Association?
Offer a terse response. 6.51e+07. What is the difference between the highest and the second highest Amount (in current US$) in Others?
Your response must be concise. 3.26e+07. What is the difference between the highest and the lowest Amount (in current US$) in Regional development banks?
Provide a short and direct response. 3.00e+07. What is the difference between the highest and the lowest Amount (in current US$) in International Monetary Fund?
Keep it short and to the point. 1.00e+08. What is the difference between the highest and the lowest Amount (in current US$) in International Development Association?
Your answer should be compact. 1.83e+08. What is the difference between the highest and the lowest Amount (in current US$) of Others?
Provide a short and direct response. 2.50e+08. 